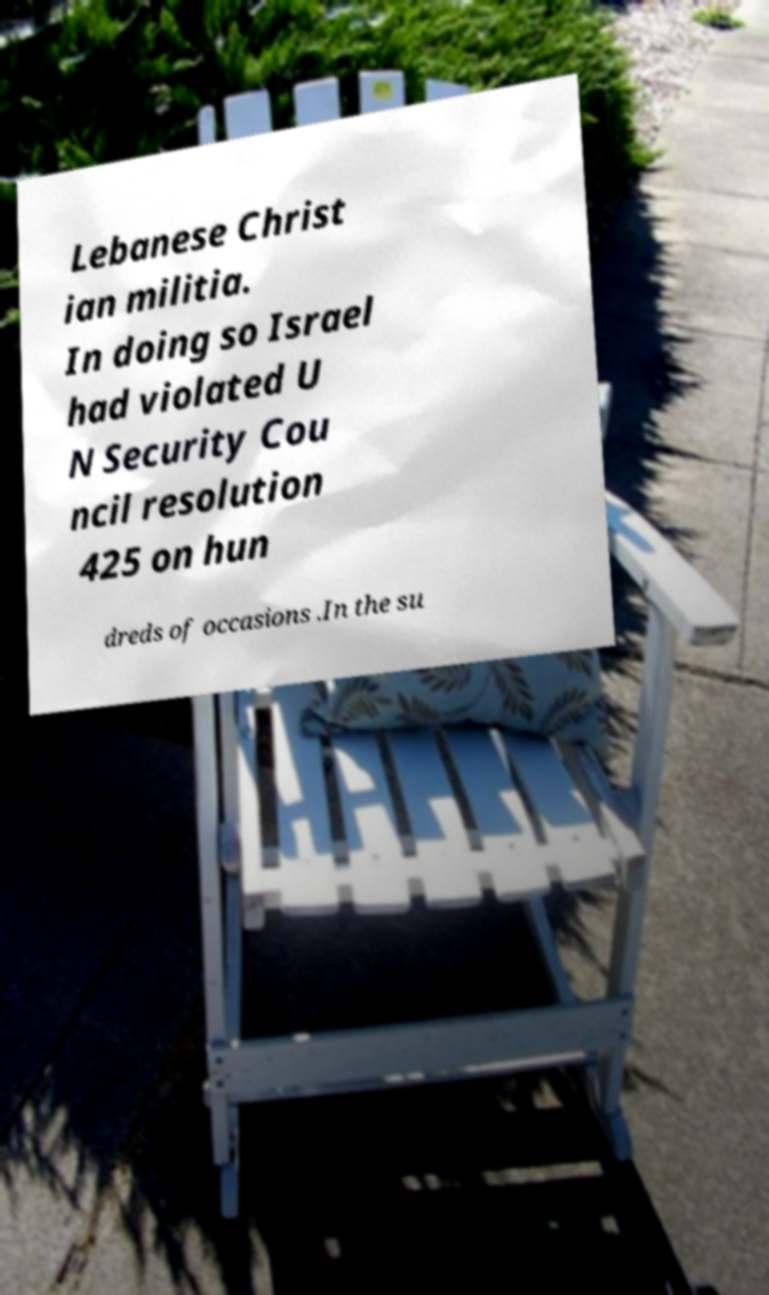For documentation purposes, I need the text within this image transcribed. Could you provide that? Lebanese Christ ian militia. In doing so Israel had violated U N Security Cou ncil resolution 425 on hun dreds of occasions .In the su 